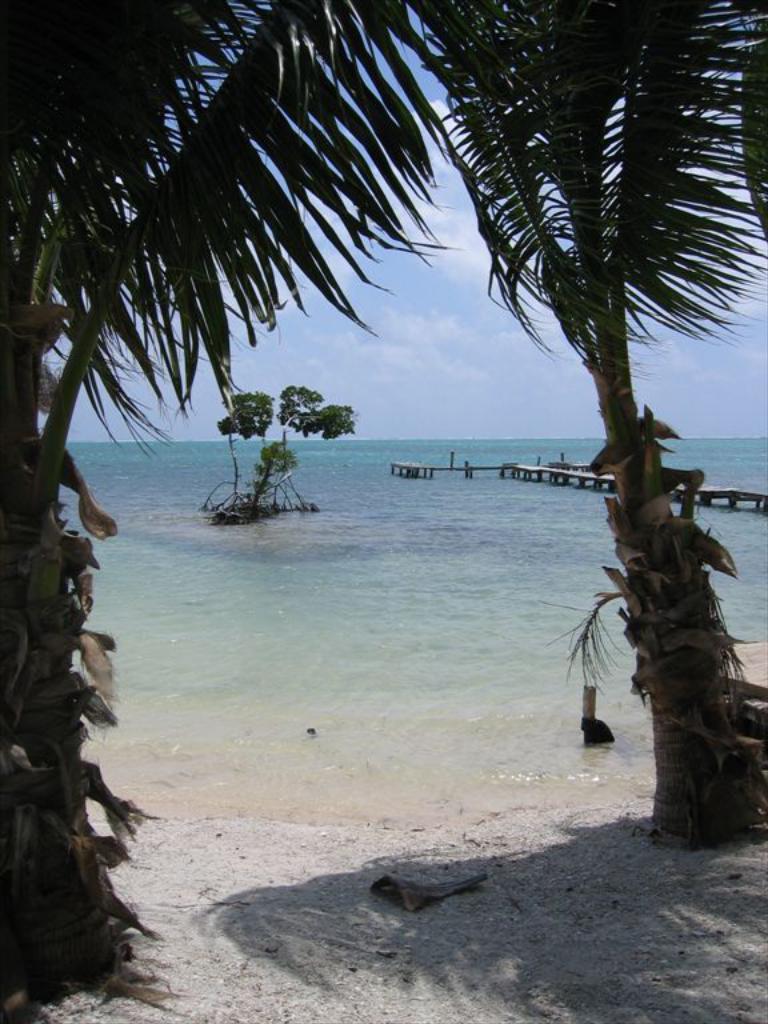How would you summarize this image in a sentence or two? Here we can see water and trees. 